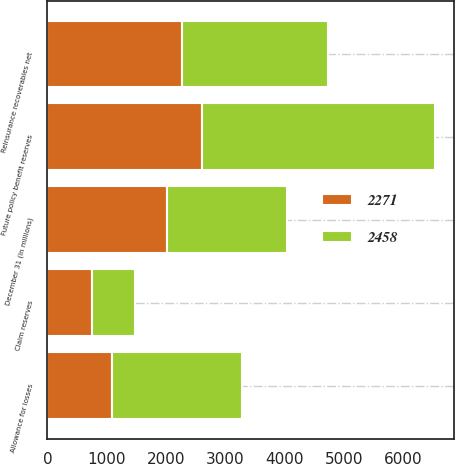Convert chart to OTSL. <chart><loc_0><loc_0><loc_500><loc_500><stacked_bar_chart><ecel><fcel>December 31 (In millions)<fcel>Future policy benefit reserves<fcel>Claim reserves<fcel>Allowance for losses<fcel>Reinsurance recoverables net<nl><fcel>2271<fcel>2018<fcel>2605<fcel>756<fcel>1090<fcel>2271<nl><fcel>2458<fcel>2017<fcel>3928<fcel>715<fcel>2185<fcel>2458<nl></chart> 